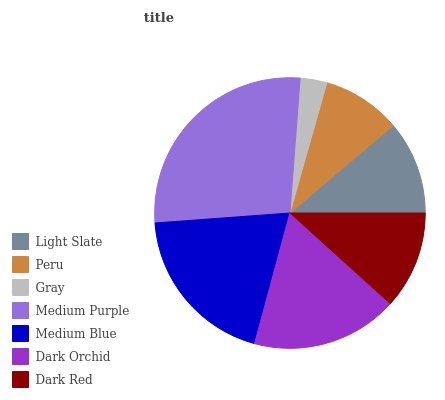Is Gray the minimum?
Answer yes or no. Yes. Is Medium Purple the maximum?
Answer yes or no. Yes. Is Peru the minimum?
Answer yes or no. No. Is Peru the maximum?
Answer yes or no. No. Is Light Slate greater than Peru?
Answer yes or no. Yes. Is Peru less than Light Slate?
Answer yes or no. Yes. Is Peru greater than Light Slate?
Answer yes or no. No. Is Light Slate less than Peru?
Answer yes or no. No. Is Dark Red the high median?
Answer yes or no. Yes. Is Dark Red the low median?
Answer yes or no. Yes. Is Gray the high median?
Answer yes or no. No. Is Medium Purple the low median?
Answer yes or no. No. 